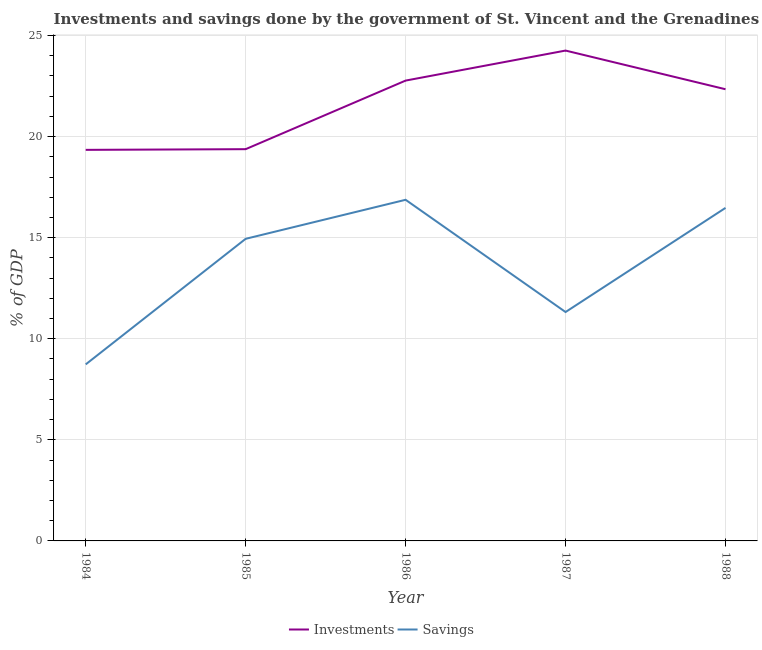How many different coloured lines are there?
Offer a very short reply. 2. What is the savings of government in 1985?
Your response must be concise. 14.95. Across all years, what is the maximum investments of government?
Your response must be concise. 24.26. Across all years, what is the minimum savings of government?
Ensure brevity in your answer.  8.73. In which year was the savings of government maximum?
Your answer should be compact. 1986. What is the total investments of government in the graph?
Your response must be concise. 108.1. What is the difference between the savings of government in 1985 and that in 1986?
Ensure brevity in your answer.  -1.93. What is the difference between the investments of government in 1986 and the savings of government in 1984?
Keep it short and to the point. 14.04. What is the average savings of government per year?
Your answer should be very brief. 13.67. In the year 1987, what is the difference between the savings of government and investments of government?
Offer a terse response. -12.93. What is the ratio of the savings of government in 1985 to that in 1986?
Your answer should be very brief. 0.89. Is the investments of government in 1987 less than that in 1988?
Offer a terse response. No. Is the difference between the savings of government in 1984 and 1987 greater than the difference between the investments of government in 1984 and 1987?
Your response must be concise. Yes. What is the difference between the highest and the second highest investments of government?
Provide a short and direct response. 1.49. What is the difference between the highest and the lowest savings of government?
Your answer should be compact. 8.14. In how many years, is the investments of government greater than the average investments of government taken over all years?
Offer a terse response. 3. Is the sum of the savings of government in 1985 and 1988 greater than the maximum investments of government across all years?
Make the answer very short. Yes. Are the values on the major ticks of Y-axis written in scientific E-notation?
Offer a very short reply. No. Does the graph contain grids?
Keep it short and to the point. Yes. Where does the legend appear in the graph?
Provide a succinct answer. Bottom center. What is the title of the graph?
Provide a succinct answer. Investments and savings done by the government of St. Vincent and the Grenadines. What is the label or title of the Y-axis?
Your answer should be very brief. % of GDP. What is the % of GDP of Investments in 1984?
Keep it short and to the point. 19.35. What is the % of GDP in Savings in 1984?
Provide a succinct answer. 8.73. What is the % of GDP of Investments in 1985?
Give a very brief answer. 19.38. What is the % of GDP in Savings in 1985?
Your answer should be very brief. 14.95. What is the % of GDP in Investments in 1986?
Keep it short and to the point. 22.77. What is the % of GDP of Savings in 1986?
Offer a very short reply. 16.88. What is the % of GDP in Investments in 1987?
Offer a very short reply. 24.26. What is the % of GDP in Savings in 1987?
Provide a succinct answer. 11.32. What is the % of GDP of Investments in 1988?
Your response must be concise. 22.34. What is the % of GDP in Savings in 1988?
Make the answer very short. 16.48. Across all years, what is the maximum % of GDP of Investments?
Make the answer very short. 24.26. Across all years, what is the maximum % of GDP in Savings?
Offer a terse response. 16.88. Across all years, what is the minimum % of GDP in Investments?
Provide a short and direct response. 19.35. Across all years, what is the minimum % of GDP of Savings?
Offer a terse response. 8.73. What is the total % of GDP in Investments in the graph?
Provide a succinct answer. 108.1. What is the total % of GDP of Savings in the graph?
Offer a very short reply. 68.35. What is the difference between the % of GDP in Investments in 1984 and that in 1985?
Your answer should be very brief. -0.03. What is the difference between the % of GDP in Savings in 1984 and that in 1985?
Provide a short and direct response. -6.21. What is the difference between the % of GDP in Investments in 1984 and that in 1986?
Your answer should be compact. -3.43. What is the difference between the % of GDP in Savings in 1984 and that in 1986?
Give a very brief answer. -8.14. What is the difference between the % of GDP in Investments in 1984 and that in 1987?
Give a very brief answer. -4.91. What is the difference between the % of GDP in Savings in 1984 and that in 1987?
Give a very brief answer. -2.59. What is the difference between the % of GDP in Investments in 1984 and that in 1988?
Provide a succinct answer. -3. What is the difference between the % of GDP of Savings in 1984 and that in 1988?
Provide a succinct answer. -7.74. What is the difference between the % of GDP in Investments in 1985 and that in 1986?
Make the answer very short. -3.39. What is the difference between the % of GDP of Savings in 1985 and that in 1986?
Your answer should be very brief. -1.93. What is the difference between the % of GDP of Investments in 1985 and that in 1987?
Provide a short and direct response. -4.88. What is the difference between the % of GDP in Savings in 1985 and that in 1987?
Provide a succinct answer. 3.62. What is the difference between the % of GDP of Investments in 1985 and that in 1988?
Your response must be concise. -2.96. What is the difference between the % of GDP of Savings in 1985 and that in 1988?
Make the answer very short. -1.53. What is the difference between the % of GDP in Investments in 1986 and that in 1987?
Make the answer very short. -1.49. What is the difference between the % of GDP in Savings in 1986 and that in 1987?
Offer a very short reply. 5.55. What is the difference between the % of GDP of Investments in 1986 and that in 1988?
Offer a terse response. 0.43. What is the difference between the % of GDP of Savings in 1986 and that in 1988?
Provide a short and direct response. 0.4. What is the difference between the % of GDP of Investments in 1987 and that in 1988?
Offer a terse response. 1.91. What is the difference between the % of GDP of Savings in 1987 and that in 1988?
Your response must be concise. -5.15. What is the difference between the % of GDP in Investments in 1984 and the % of GDP in Savings in 1985?
Your answer should be very brief. 4.4. What is the difference between the % of GDP in Investments in 1984 and the % of GDP in Savings in 1986?
Your response must be concise. 2.47. What is the difference between the % of GDP of Investments in 1984 and the % of GDP of Savings in 1987?
Give a very brief answer. 8.02. What is the difference between the % of GDP in Investments in 1984 and the % of GDP in Savings in 1988?
Your answer should be very brief. 2.87. What is the difference between the % of GDP in Investments in 1985 and the % of GDP in Savings in 1986?
Offer a terse response. 2.5. What is the difference between the % of GDP in Investments in 1985 and the % of GDP in Savings in 1987?
Provide a succinct answer. 8.06. What is the difference between the % of GDP in Investments in 1985 and the % of GDP in Savings in 1988?
Provide a short and direct response. 2.91. What is the difference between the % of GDP of Investments in 1986 and the % of GDP of Savings in 1987?
Make the answer very short. 11.45. What is the difference between the % of GDP of Investments in 1986 and the % of GDP of Savings in 1988?
Provide a succinct answer. 6.3. What is the difference between the % of GDP in Investments in 1987 and the % of GDP in Savings in 1988?
Your answer should be very brief. 7.78. What is the average % of GDP of Investments per year?
Your answer should be very brief. 21.62. What is the average % of GDP in Savings per year?
Provide a succinct answer. 13.67. In the year 1984, what is the difference between the % of GDP in Investments and % of GDP in Savings?
Provide a succinct answer. 10.61. In the year 1985, what is the difference between the % of GDP of Investments and % of GDP of Savings?
Your answer should be compact. 4.43. In the year 1986, what is the difference between the % of GDP in Investments and % of GDP in Savings?
Provide a short and direct response. 5.9. In the year 1987, what is the difference between the % of GDP in Investments and % of GDP in Savings?
Give a very brief answer. 12.93. In the year 1988, what is the difference between the % of GDP in Investments and % of GDP in Savings?
Offer a terse response. 5.87. What is the ratio of the % of GDP in Savings in 1984 to that in 1985?
Keep it short and to the point. 0.58. What is the ratio of the % of GDP in Investments in 1984 to that in 1986?
Offer a very short reply. 0.85. What is the ratio of the % of GDP in Savings in 1984 to that in 1986?
Offer a very short reply. 0.52. What is the ratio of the % of GDP in Investments in 1984 to that in 1987?
Give a very brief answer. 0.8. What is the ratio of the % of GDP in Savings in 1984 to that in 1987?
Keep it short and to the point. 0.77. What is the ratio of the % of GDP of Investments in 1984 to that in 1988?
Ensure brevity in your answer.  0.87. What is the ratio of the % of GDP of Savings in 1984 to that in 1988?
Make the answer very short. 0.53. What is the ratio of the % of GDP of Investments in 1985 to that in 1986?
Make the answer very short. 0.85. What is the ratio of the % of GDP in Savings in 1985 to that in 1986?
Offer a very short reply. 0.89. What is the ratio of the % of GDP of Investments in 1985 to that in 1987?
Keep it short and to the point. 0.8. What is the ratio of the % of GDP of Savings in 1985 to that in 1987?
Provide a succinct answer. 1.32. What is the ratio of the % of GDP in Investments in 1985 to that in 1988?
Provide a succinct answer. 0.87. What is the ratio of the % of GDP in Savings in 1985 to that in 1988?
Your answer should be very brief. 0.91. What is the ratio of the % of GDP in Investments in 1986 to that in 1987?
Your answer should be compact. 0.94. What is the ratio of the % of GDP of Savings in 1986 to that in 1987?
Your answer should be compact. 1.49. What is the ratio of the % of GDP of Investments in 1986 to that in 1988?
Your response must be concise. 1.02. What is the ratio of the % of GDP of Savings in 1986 to that in 1988?
Provide a succinct answer. 1.02. What is the ratio of the % of GDP in Investments in 1987 to that in 1988?
Give a very brief answer. 1.09. What is the ratio of the % of GDP of Savings in 1987 to that in 1988?
Provide a short and direct response. 0.69. What is the difference between the highest and the second highest % of GDP of Investments?
Your answer should be very brief. 1.49. What is the difference between the highest and the second highest % of GDP of Savings?
Offer a terse response. 0.4. What is the difference between the highest and the lowest % of GDP of Investments?
Offer a very short reply. 4.91. What is the difference between the highest and the lowest % of GDP of Savings?
Offer a very short reply. 8.14. 